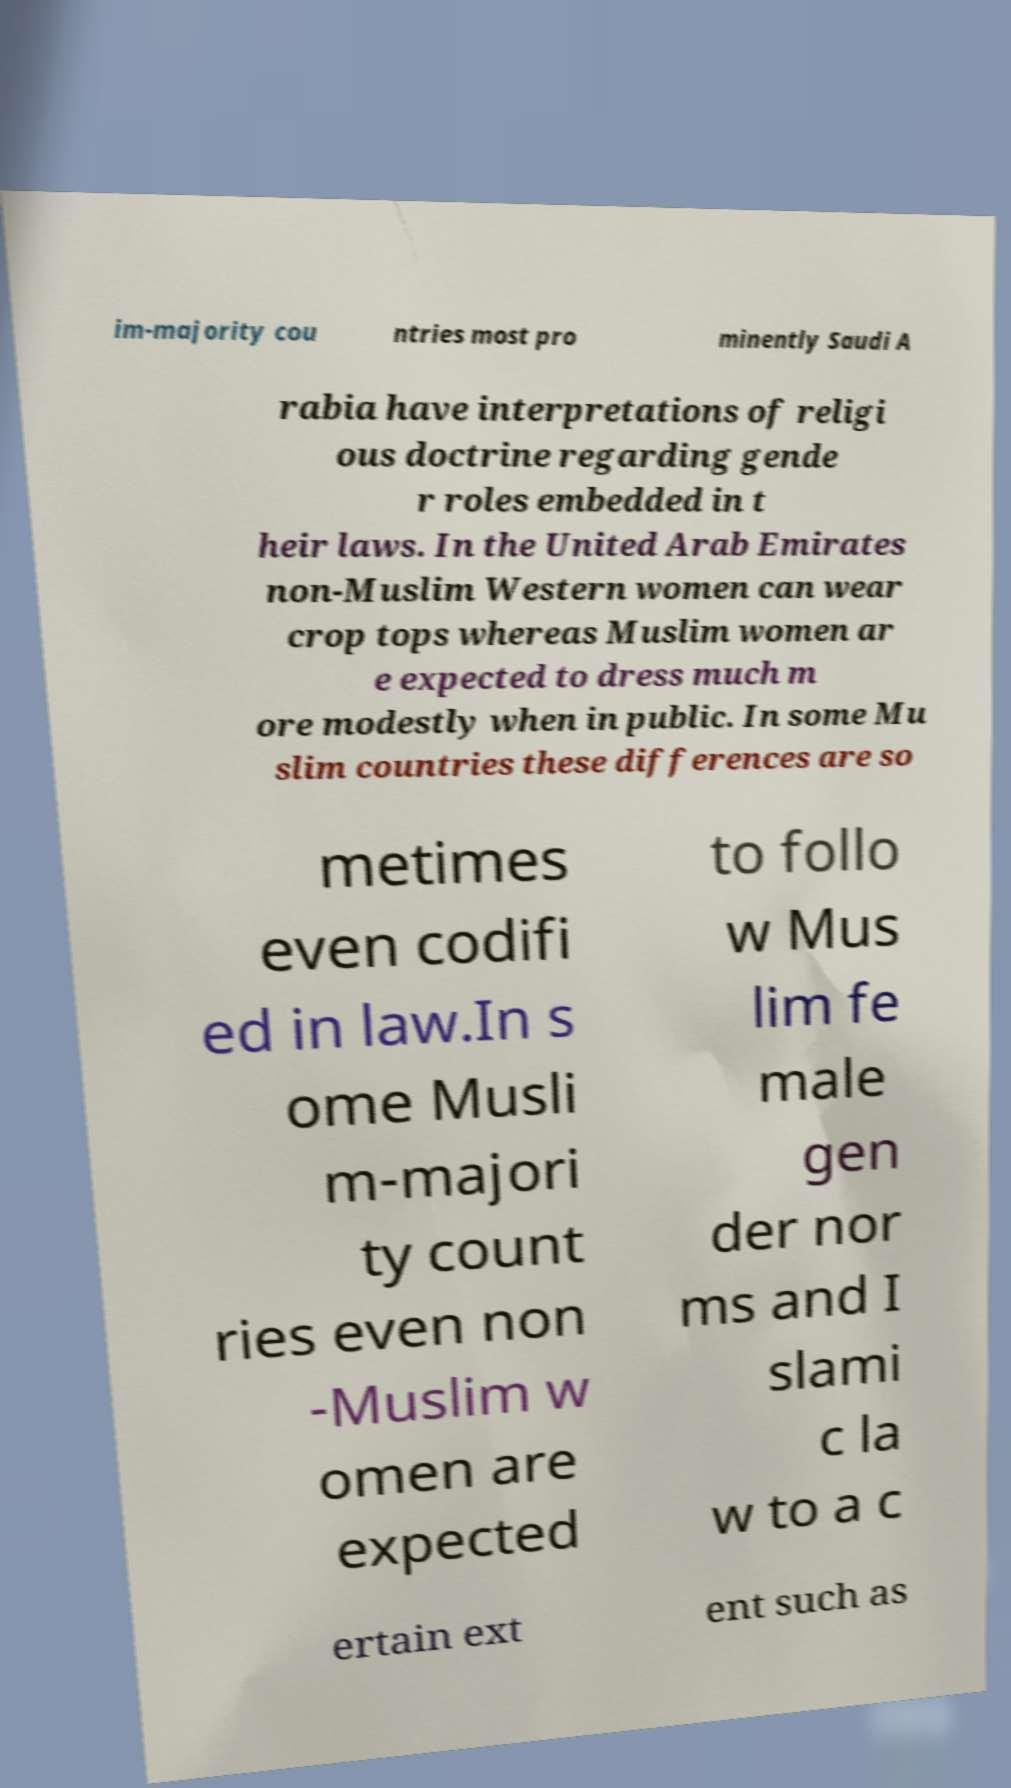There's text embedded in this image that I need extracted. Can you transcribe it verbatim? im-majority cou ntries most pro minently Saudi A rabia have interpretations of religi ous doctrine regarding gende r roles embedded in t heir laws. In the United Arab Emirates non-Muslim Western women can wear crop tops whereas Muslim women ar e expected to dress much m ore modestly when in public. In some Mu slim countries these differences are so metimes even codifi ed in law.In s ome Musli m-majori ty count ries even non -Muslim w omen are expected to follo w Mus lim fe male gen der nor ms and I slami c la w to a c ertain ext ent such as 